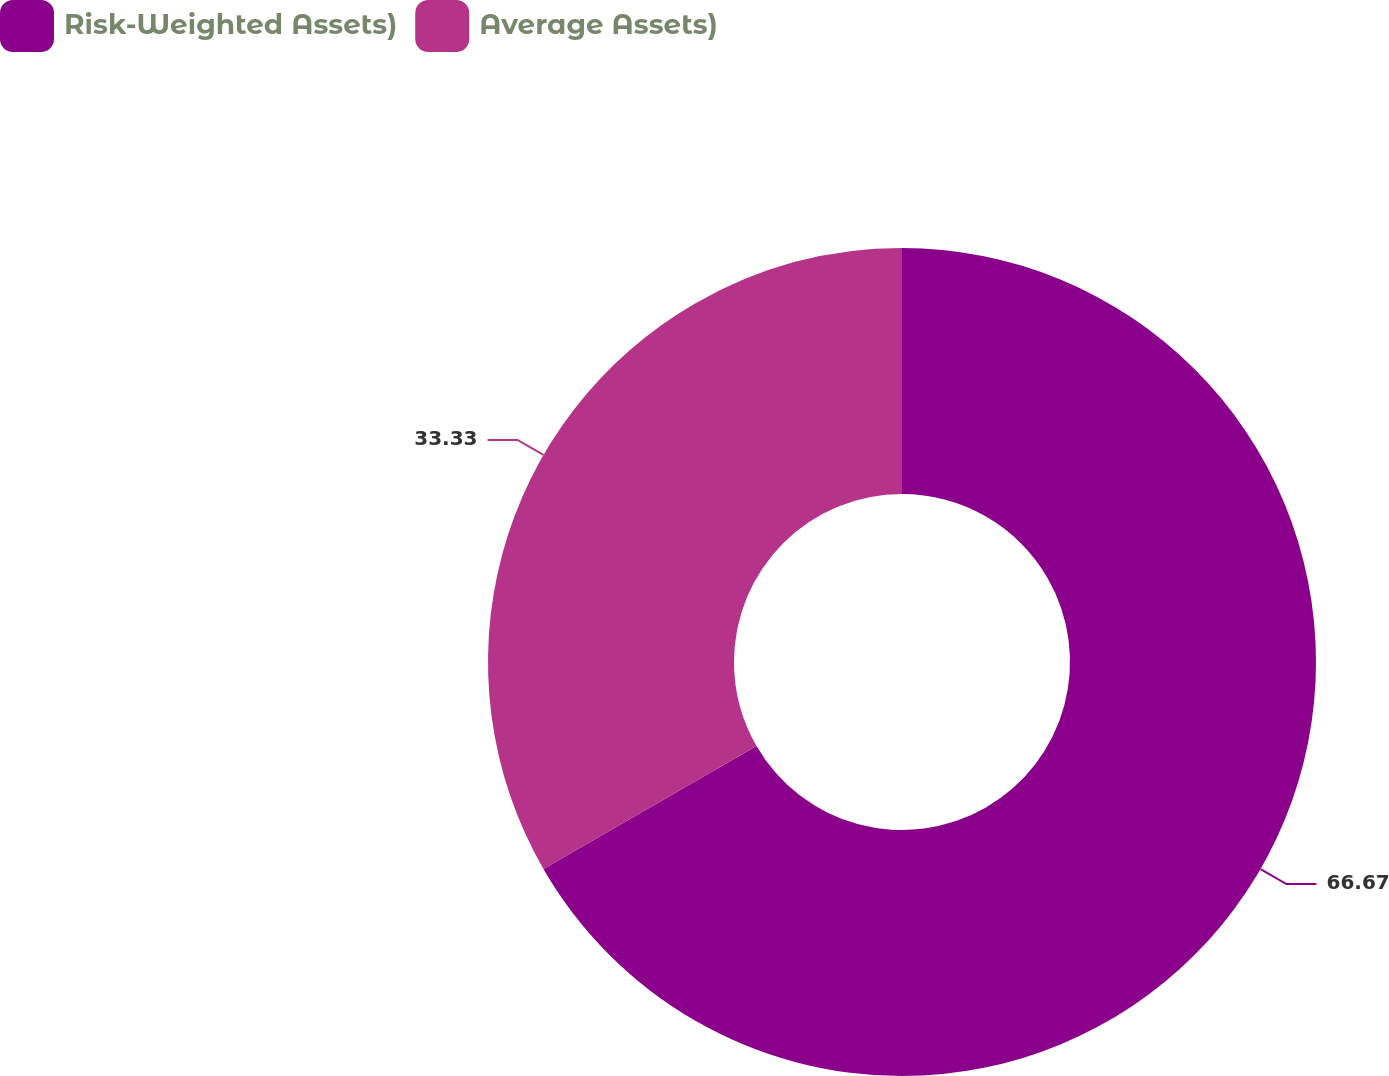<chart> <loc_0><loc_0><loc_500><loc_500><pie_chart><fcel>Risk-Weighted Assets)<fcel>Average Assets)<nl><fcel>66.67%<fcel>33.33%<nl></chart> 